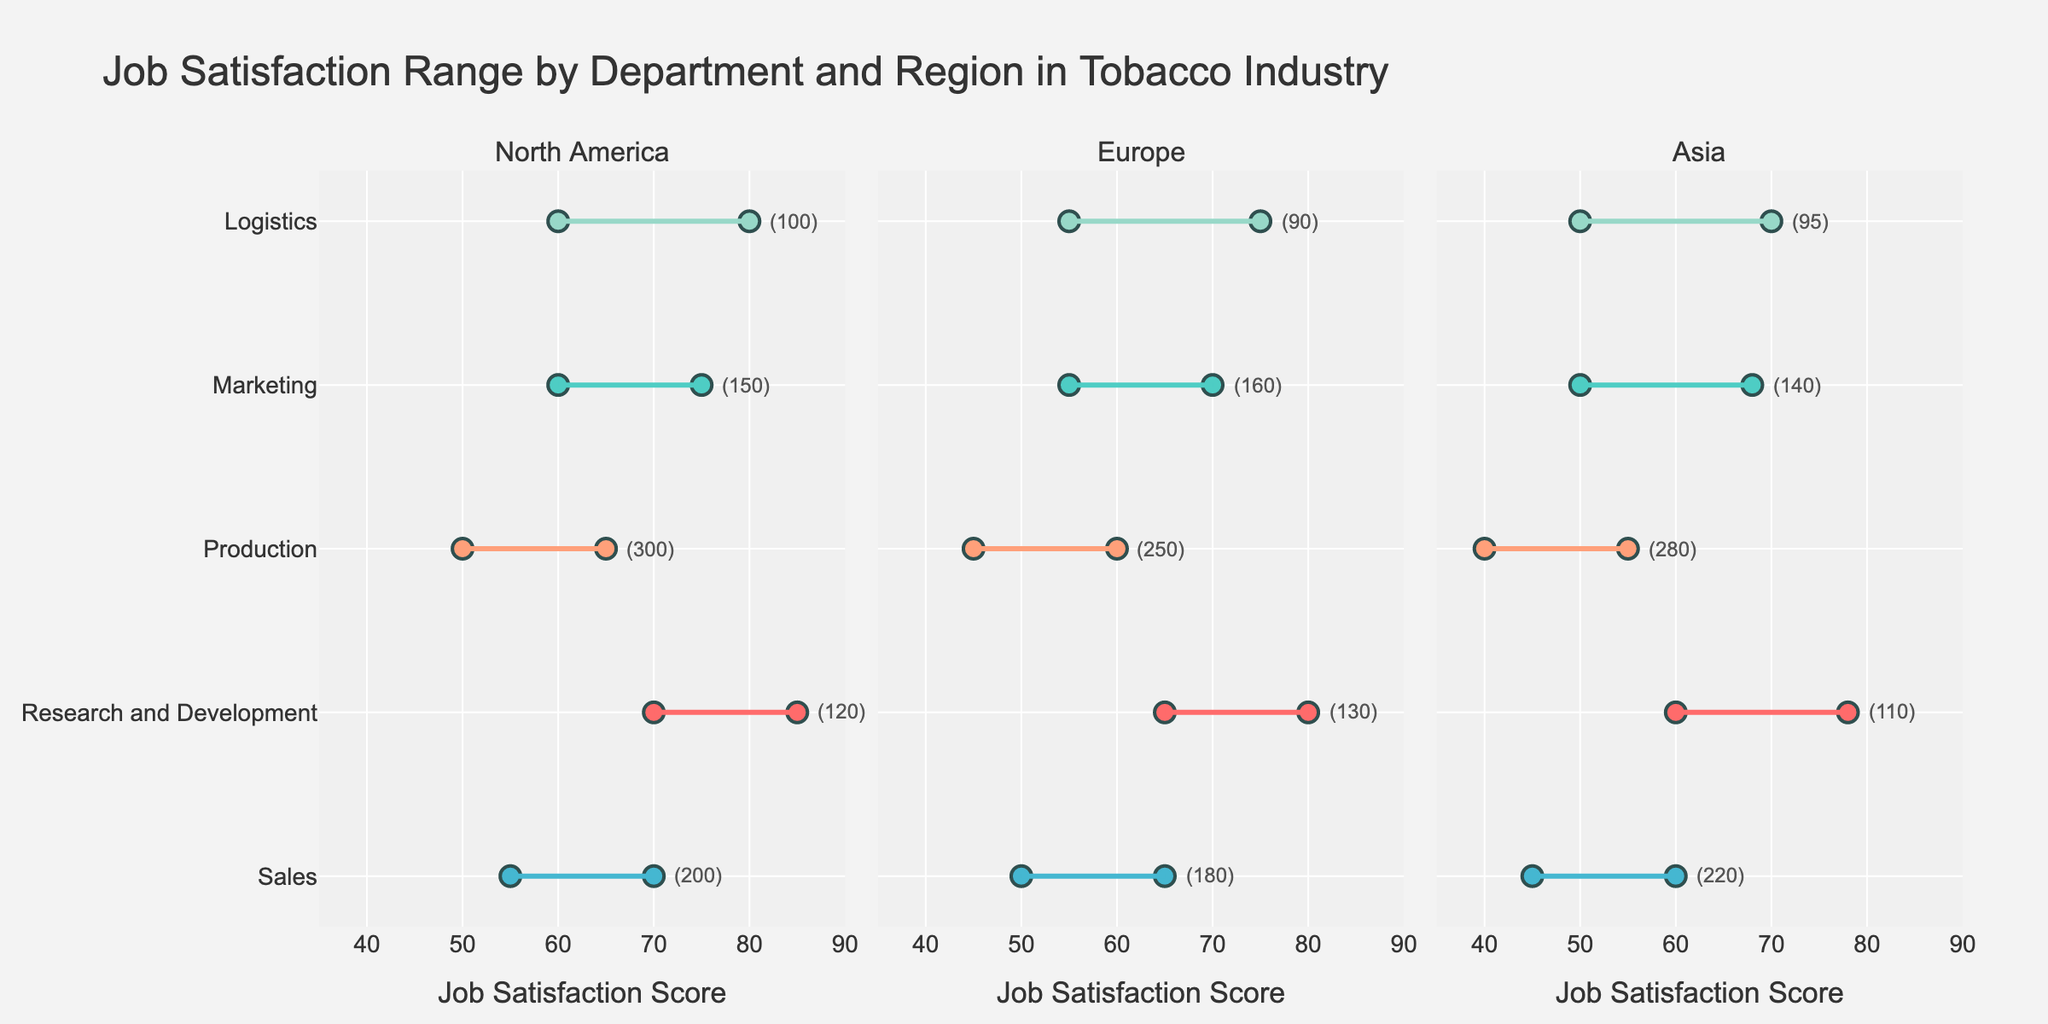What is the maximum job satisfaction score for the Research and Development department in North America? Look at the plot for North America, and find the maximum value for the job satisfaction in the Research and Development department.
Answer: 85 Which region has the highest minimum job satisfaction score in the Marketing department? Compare the minimum job satisfaction scores for the Marketing department across North America, Europe, and Asia.
Answer: North America How many employees are in the Production department in Europe? Refer to the annotation next to the Production department in the Europe subplot.
Answer: 250 What is the range of job satisfaction scores in the Sales department in Asia? Find the minimum and maximum job satisfaction scores for the Sales department in Asia and subtract the minimum from the maximum.
Answer: 15 Which department in North America has the most significant difference between minimum and maximum job satisfaction scores? Calculate the difference between the maximum and minimum job satisfaction scores for each department in North America, and compare them to find the largest difference.
Answer: Logistics What is the average maximum job satisfaction score across all departments in Europe? Sum up the maximum job satisfaction scores across all departments in Europe and divide by the number of departments.
Answer: 70 Which region has the lowest maximum job satisfaction score for the Production department? Compare the maximum job satisfaction scores for the Production department across North America, Europe, and Asia.
Answer: Asia How does the range of job satisfaction scores in the Logistics department in North America compare to that in Europe? Calculate the range by subtracting the minimum from the maximum job satisfaction scores for the Logistics department in both North America and Europe, then compare the ranges.
Answer: North America: 20, Europe: 20; they are the same What is the employee count for the Sales department in Asia? Refer to the annotation next to the Sales department in the Asia subplot.
Answer: 220 